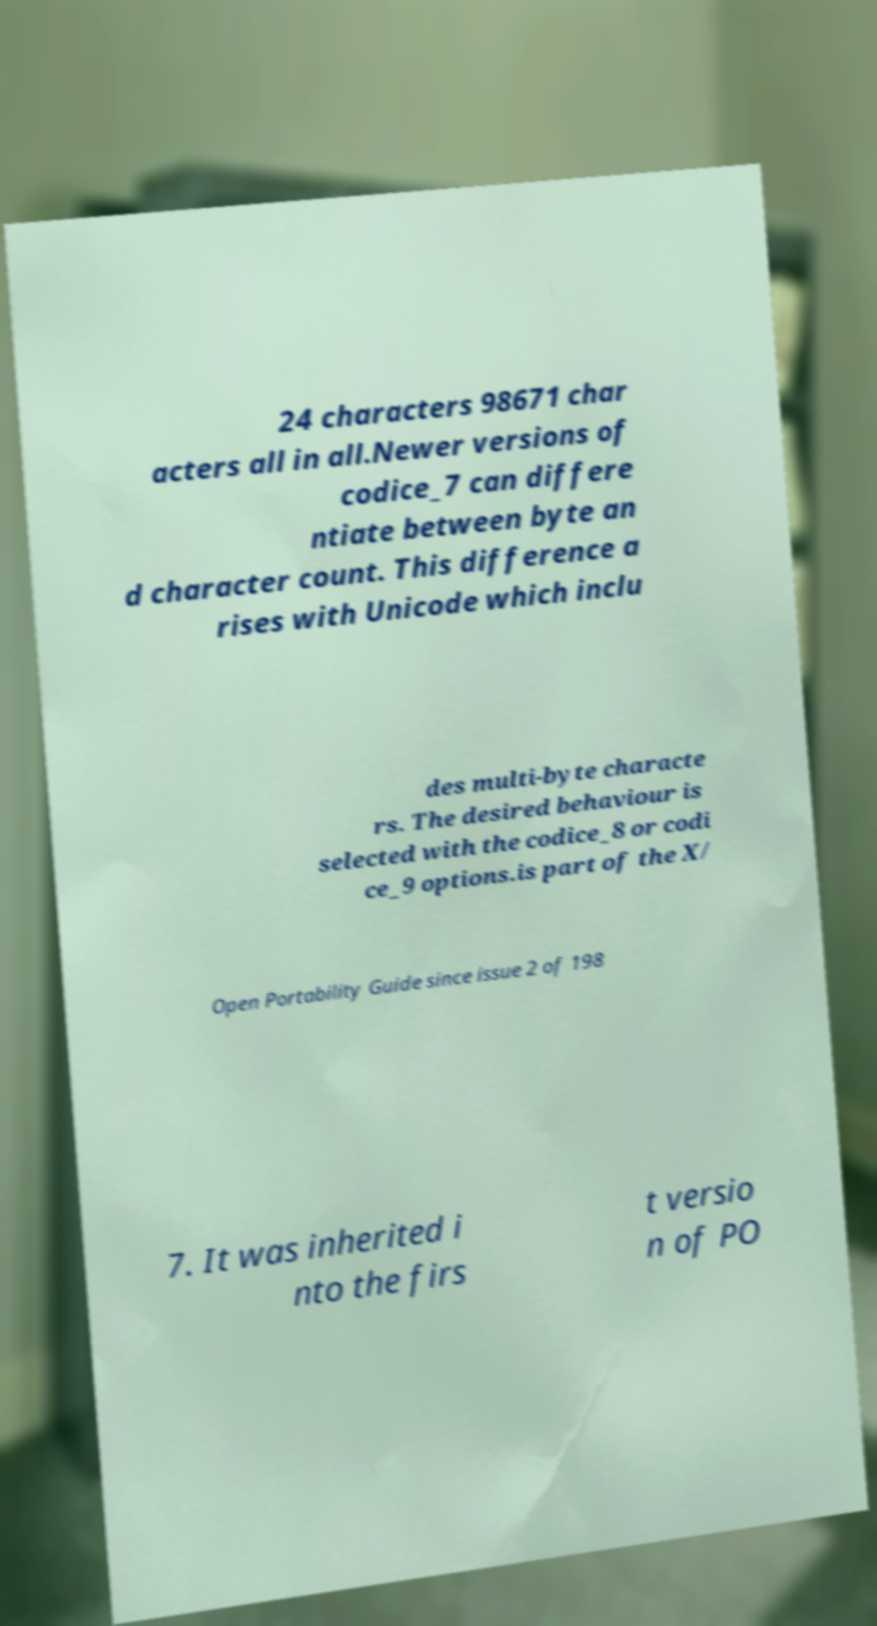For documentation purposes, I need the text within this image transcribed. Could you provide that? 24 characters 98671 char acters all in all.Newer versions of codice_7 can differe ntiate between byte an d character count. This difference a rises with Unicode which inclu des multi-byte characte rs. The desired behaviour is selected with the codice_8 or codi ce_9 options.is part of the X/ Open Portability Guide since issue 2 of 198 7. It was inherited i nto the firs t versio n of PO 